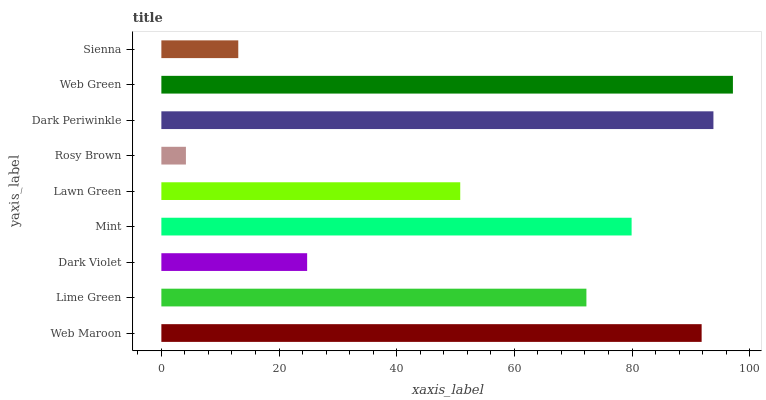Is Rosy Brown the minimum?
Answer yes or no. Yes. Is Web Green the maximum?
Answer yes or no. Yes. Is Lime Green the minimum?
Answer yes or no. No. Is Lime Green the maximum?
Answer yes or no. No. Is Web Maroon greater than Lime Green?
Answer yes or no. Yes. Is Lime Green less than Web Maroon?
Answer yes or no. Yes. Is Lime Green greater than Web Maroon?
Answer yes or no. No. Is Web Maroon less than Lime Green?
Answer yes or no. No. Is Lime Green the high median?
Answer yes or no. Yes. Is Lime Green the low median?
Answer yes or no. Yes. Is Web Green the high median?
Answer yes or no. No. Is Dark Periwinkle the low median?
Answer yes or no. No. 